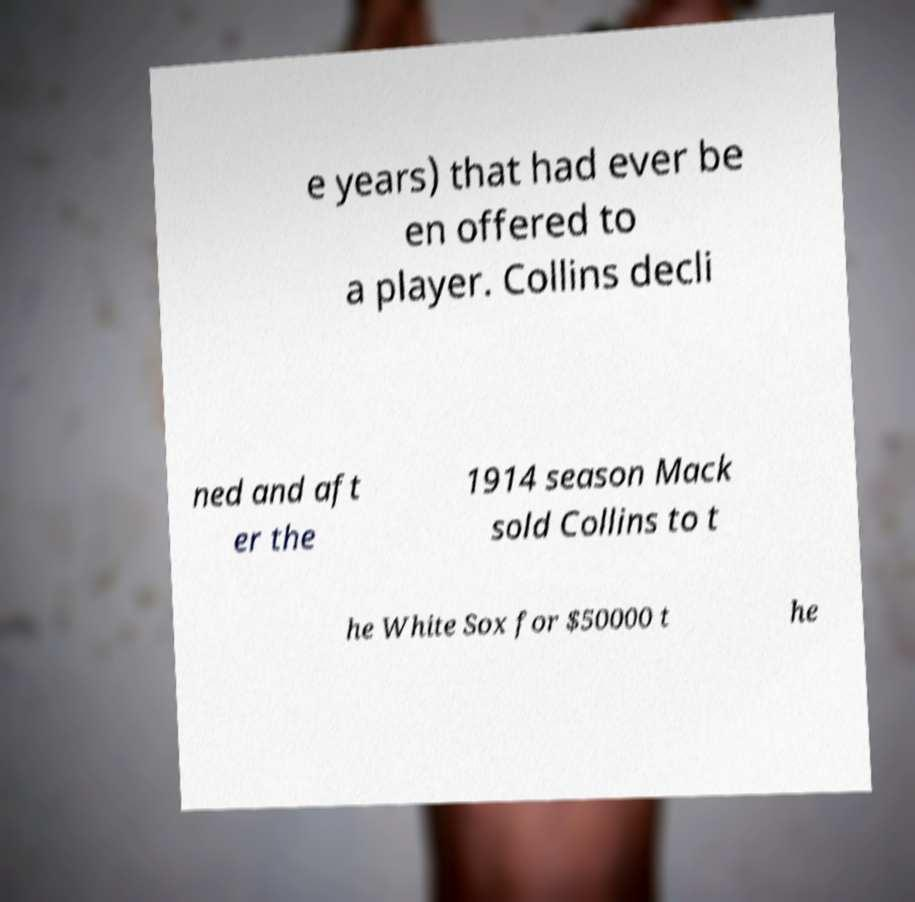Please read and relay the text visible in this image. What does it say? e years) that had ever be en offered to a player. Collins decli ned and aft er the 1914 season Mack sold Collins to t he White Sox for $50000 t he 